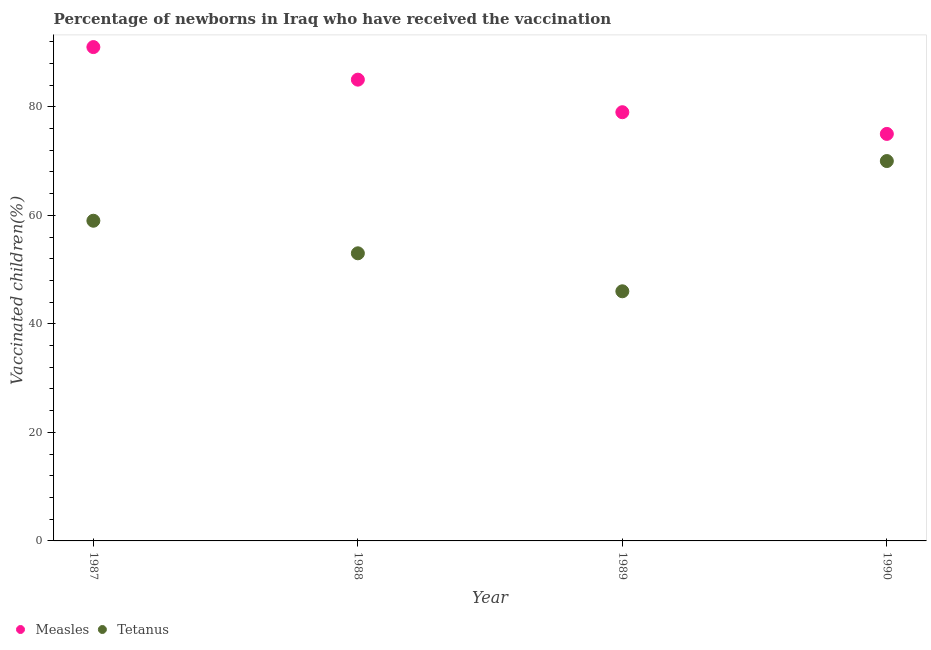Is the number of dotlines equal to the number of legend labels?
Your answer should be compact. Yes. What is the percentage of newborns who received vaccination for tetanus in 1989?
Your response must be concise. 46. Across all years, what is the maximum percentage of newborns who received vaccination for tetanus?
Offer a terse response. 70. Across all years, what is the minimum percentage of newborns who received vaccination for tetanus?
Give a very brief answer. 46. In which year was the percentage of newborns who received vaccination for tetanus maximum?
Offer a very short reply. 1990. What is the total percentage of newborns who received vaccination for measles in the graph?
Make the answer very short. 330. What is the difference between the percentage of newborns who received vaccination for measles in 1987 and that in 1988?
Your answer should be compact. 6. What is the difference between the percentage of newborns who received vaccination for measles in 1987 and the percentage of newborns who received vaccination for tetanus in 1990?
Make the answer very short. 21. What is the average percentage of newborns who received vaccination for tetanus per year?
Offer a terse response. 57. In the year 1987, what is the difference between the percentage of newborns who received vaccination for measles and percentage of newborns who received vaccination for tetanus?
Provide a succinct answer. 32. What is the ratio of the percentage of newborns who received vaccination for measles in 1987 to that in 1990?
Provide a succinct answer. 1.21. Is the percentage of newborns who received vaccination for tetanus in 1987 less than that in 1988?
Ensure brevity in your answer.  No. Is the difference between the percentage of newborns who received vaccination for measles in 1988 and 1989 greater than the difference between the percentage of newborns who received vaccination for tetanus in 1988 and 1989?
Keep it short and to the point. No. What is the difference between the highest and the second highest percentage of newborns who received vaccination for measles?
Make the answer very short. 6. What is the difference between the highest and the lowest percentage of newborns who received vaccination for measles?
Keep it short and to the point. 16. In how many years, is the percentage of newborns who received vaccination for tetanus greater than the average percentage of newborns who received vaccination for tetanus taken over all years?
Your answer should be very brief. 2. Is the sum of the percentage of newborns who received vaccination for measles in 1987 and 1989 greater than the maximum percentage of newborns who received vaccination for tetanus across all years?
Ensure brevity in your answer.  Yes. Does the percentage of newborns who received vaccination for measles monotonically increase over the years?
Make the answer very short. No. Is the percentage of newborns who received vaccination for measles strictly less than the percentage of newborns who received vaccination for tetanus over the years?
Your answer should be compact. No. How many years are there in the graph?
Give a very brief answer. 4. Are the values on the major ticks of Y-axis written in scientific E-notation?
Give a very brief answer. No. How are the legend labels stacked?
Offer a very short reply. Horizontal. What is the title of the graph?
Your answer should be very brief. Percentage of newborns in Iraq who have received the vaccination. What is the label or title of the X-axis?
Your response must be concise. Year. What is the label or title of the Y-axis?
Your response must be concise. Vaccinated children(%)
. What is the Vaccinated children(%)
 in Measles in 1987?
Your answer should be compact. 91. What is the Vaccinated children(%)
 of Measles in 1988?
Provide a succinct answer. 85. What is the Vaccinated children(%)
 in Tetanus in 1988?
Provide a short and direct response. 53. What is the Vaccinated children(%)
 in Measles in 1989?
Provide a short and direct response. 79. What is the Vaccinated children(%)
 of Measles in 1990?
Your answer should be compact. 75. What is the Vaccinated children(%)
 in Tetanus in 1990?
Provide a succinct answer. 70. Across all years, what is the maximum Vaccinated children(%)
 in Measles?
Keep it short and to the point. 91. What is the total Vaccinated children(%)
 of Measles in the graph?
Your answer should be very brief. 330. What is the total Vaccinated children(%)
 in Tetanus in the graph?
Make the answer very short. 228. What is the difference between the Vaccinated children(%)
 of Measles in 1987 and that in 1988?
Your answer should be very brief. 6. What is the difference between the Vaccinated children(%)
 of Measles in 1987 and that in 1989?
Keep it short and to the point. 12. What is the difference between the Vaccinated children(%)
 of Tetanus in 1987 and that in 1989?
Your answer should be very brief. 13. What is the difference between the Vaccinated children(%)
 of Measles in 1987 and that in 1990?
Offer a very short reply. 16. What is the difference between the Vaccinated children(%)
 in Tetanus in 1987 and that in 1990?
Provide a short and direct response. -11. What is the difference between the Vaccinated children(%)
 in Tetanus in 1988 and that in 1990?
Keep it short and to the point. -17. What is the difference between the Vaccinated children(%)
 in Measles in 1987 and the Vaccinated children(%)
 in Tetanus in 1990?
Your answer should be very brief. 21. What is the difference between the Vaccinated children(%)
 in Measles in 1989 and the Vaccinated children(%)
 in Tetanus in 1990?
Give a very brief answer. 9. What is the average Vaccinated children(%)
 in Measles per year?
Give a very brief answer. 82.5. In the year 1987, what is the difference between the Vaccinated children(%)
 in Measles and Vaccinated children(%)
 in Tetanus?
Make the answer very short. 32. In the year 1989, what is the difference between the Vaccinated children(%)
 in Measles and Vaccinated children(%)
 in Tetanus?
Ensure brevity in your answer.  33. In the year 1990, what is the difference between the Vaccinated children(%)
 in Measles and Vaccinated children(%)
 in Tetanus?
Ensure brevity in your answer.  5. What is the ratio of the Vaccinated children(%)
 of Measles in 1987 to that in 1988?
Your answer should be compact. 1.07. What is the ratio of the Vaccinated children(%)
 in Tetanus in 1987 to that in 1988?
Ensure brevity in your answer.  1.11. What is the ratio of the Vaccinated children(%)
 in Measles in 1987 to that in 1989?
Your answer should be very brief. 1.15. What is the ratio of the Vaccinated children(%)
 in Tetanus in 1987 to that in 1989?
Give a very brief answer. 1.28. What is the ratio of the Vaccinated children(%)
 in Measles in 1987 to that in 1990?
Your answer should be compact. 1.21. What is the ratio of the Vaccinated children(%)
 of Tetanus in 1987 to that in 1990?
Provide a succinct answer. 0.84. What is the ratio of the Vaccinated children(%)
 of Measles in 1988 to that in 1989?
Provide a succinct answer. 1.08. What is the ratio of the Vaccinated children(%)
 in Tetanus in 1988 to that in 1989?
Your answer should be very brief. 1.15. What is the ratio of the Vaccinated children(%)
 of Measles in 1988 to that in 1990?
Give a very brief answer. 1.13. What is the ratio of the Vaccinated children(%)
 of Tetanus in 1988 to that in 1990?
Give a very brief answer. 0.76. What is the ratio of the Vaccinated children(%)
 in Measles in 1989 to that in 1990?
Provide a succinct answer. 1.05. What is the ratio of the Vaccinated children(%)
 in Tetanus in 1989 to that in 1990?
Your answer should be very brief. 0.66. What is the difference between the highest and the second highest Vaccinated children(%)
 of Measles?
Your answer should be very brief. 6. 